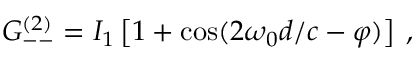<formula> <loc_0><loc_0><loc_500><loc_500>G _ { - - } ^ { ( 2 ) } = I _ { 1 } \left [ 1 + \cos ( 2 \omega _ { 0 } d / c - \varphi ) \right ] \, ,</formula> 